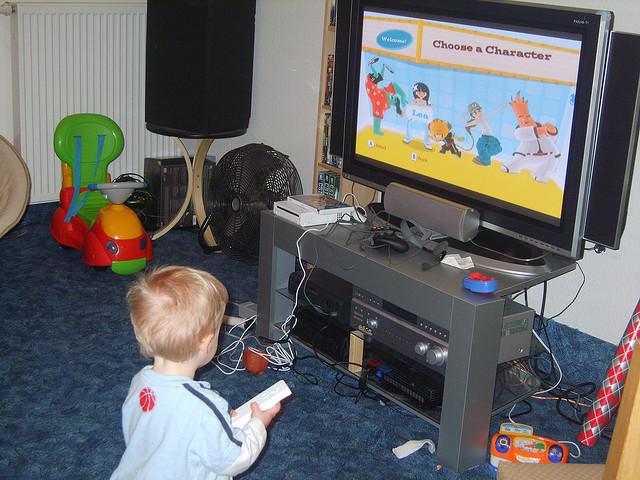What type of game console is the child playing?
Answer briefly. Wii. What color is the wrapping paper?
Quick response, please. Red and silver. What game system is this little boy playing?
Give a very brief answer. Wii. What is on the back of the child's shirt?
Give a very brief answer. Basketball. 